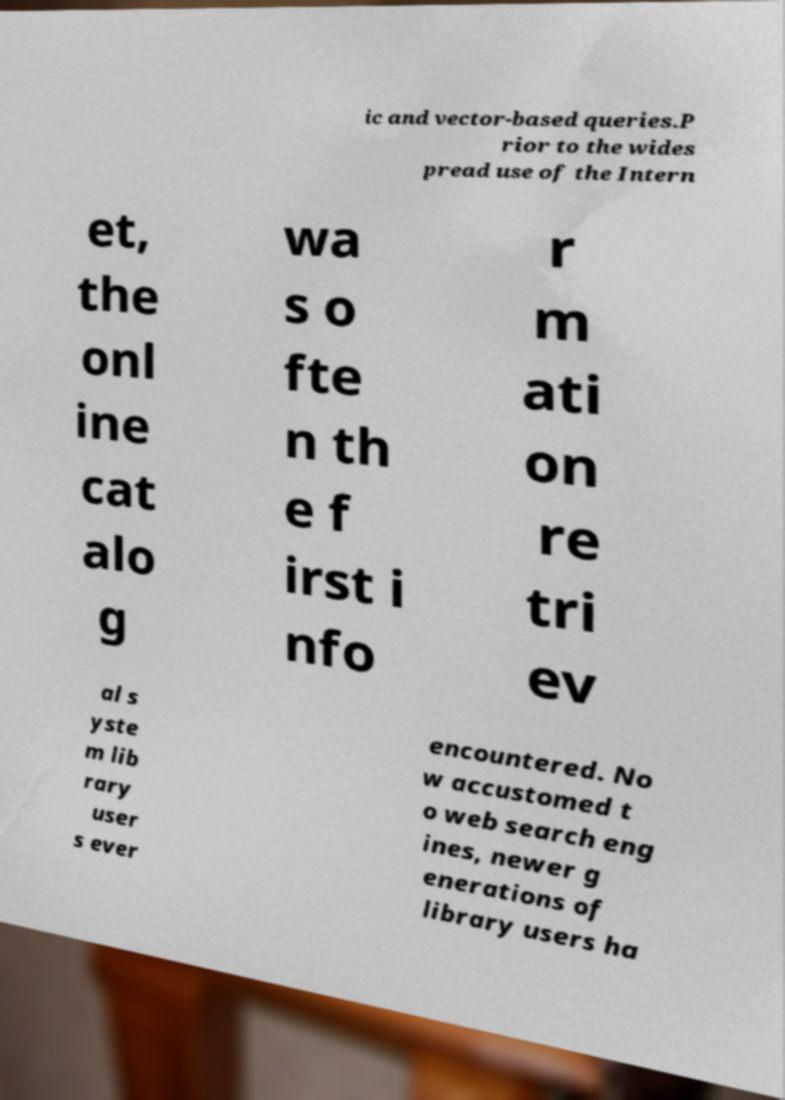Please identify and transcribe the text found in this image. ic and vector-based queries.P rior to the wides pread use of the Intern et, the onl ine cat alo g wa s o fte n th e f irst i nfo r m ati on re tri ev al s yste m lib rary user s ever encountered. No w accustomed t o web search eng ines, newer g enerations of library users ha 